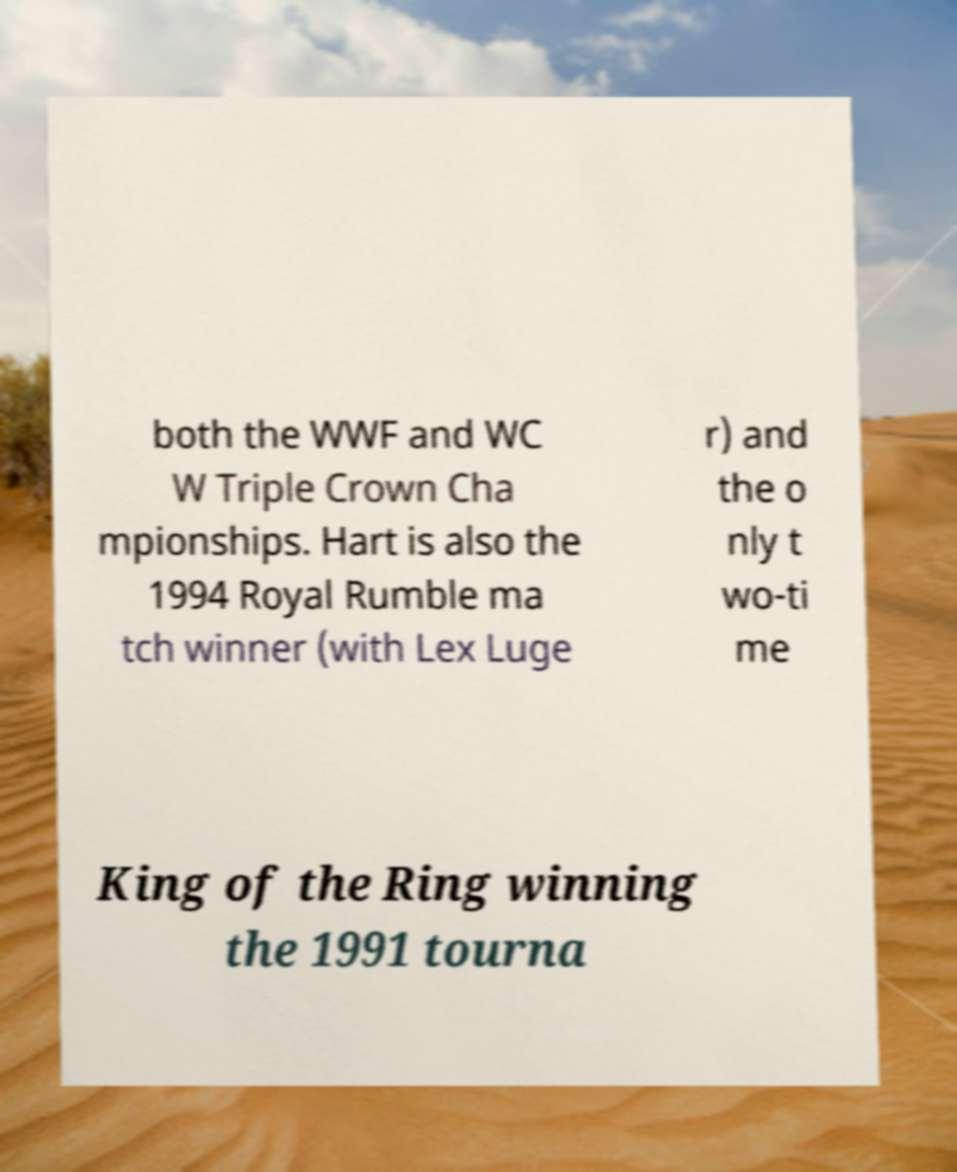Can you accurately transcribe the text from the provided image for me? both the WWF and WC W Triple Crown Cha mpionships. Hart is also the 1994 Royal Rumble ma tch winner (with Lex Luge r) and the o nly t wo-ti me King of the Ring winning the 1991 tourna 